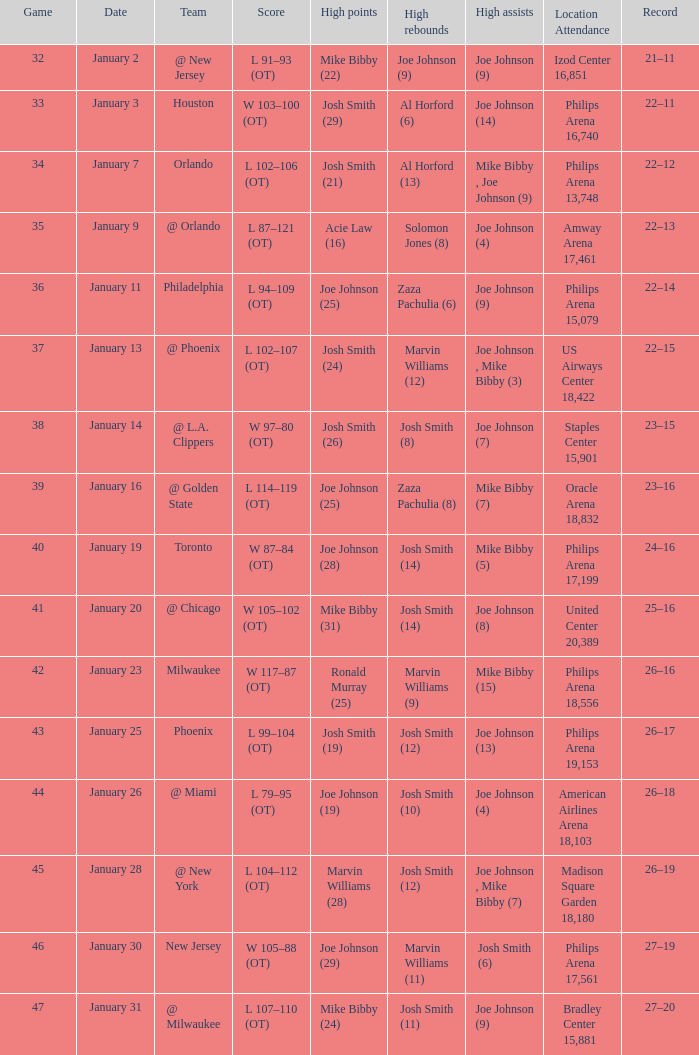Which date was game 35 on? January 9. Give me the full table as a dictionary. {'header': ['Game', 'Date', 'Team', 'Score', 'High points', 'High rebounds', 'High assists', 'Location Attendance', 'Record'], 'rows': [['32', 'January 2', '@ New Jersey', 'L 91–93 (OT)', 'Mike Bibby (22)', 'Joe Johnson (9)', 'Joe Johnson (9)', 'Izod Center 16,851', '21–11'], ['33', 'January 3', 'Houston', 'W 103–100 (OT)', 'Josh Smith (29)', 'Al Horford (6)', 'Joe Johnson (14)', 'Philips Arena 16,740', '22–11'], ['34', 'January 7', 'Orlando', 'L 102–106 (OT)', 'Josh Smith (21)', 'Al Horford (13)', 'Mike Bibby , Joe Johnson (9)', 'Philips Arena 13,748', '22–12'], ['35', 'January 9', '@ Orlando', 'L 87–121 (OT)', 'Acie Law (16)', 'Solomon Jones (8)', 'Joe Johnson (4)', 'Amway Arena 17,461', '22–13'], ['36', 'January 11', 'Philadelphia', 'L 94–109 (OT)', 'Joe Johnson (25)', 'Zaza Pachulia (6)', 'Joe Johnson (9)', 'Philips Arena 15,079', '22–14'], ['37', 'January 13', '@ Phoenix', 'L 102–107 (OT)', 'Josh Smith (24)', 'Marvin Williams (12)', 'Joe Johnson , Mike Bibby (3)', 'US Airways Center 18,422', '22–15'], ['38', 'January 14', '@ L.A. Clippers', 'W 97–80 (OT)', 'Josh Smith (26)', 'Josh Smith (8)', 'Joe Johnson (7)', 'Staples Center 15,901', '23–15'], ['39', 'January 16', '@ Golden State', 'L 114–119 (OT)', 'Joe Johnson (25)', 'Zaza Pachulia (8)', 'Mike Bibby (7)', 'Oracle Arena 18,832', '23–16'], ['40', 'January 19', 'Toronto', 'W 87–84 (OT)', 'Joe Johnson (28)', 'Josh Smith (14)', 'Mike Bibby (5)', 'Philips Arena 17,199', '24–16'], ['41', 'January 20', '@ Chicago', 'W 105–102 (OT)', 'Mike Bibby (31)', 'Josh Smith (14)', 'Joe Johnson (8)', 'United Center 20,389', '25–16'], ['42', 'January 23', 'Milwaukee', 'W 117–87 (OT)', 'Ronald Murray (25)', 'Marvin Williams (9)', 'Mike Bibby (15)', 'Philips Arena 18,556', '26–16'], ['43', 'January 25', 'Phoenix', 'L 99–104 (OT)', 'Josh Smith (19)', 'Josh Smith (12)', 'Joe Johnson (13)', 'Philips Arena 19,153', '26–17'], ['44', 'January 26', '@ Miami', 'L 79–95 (OT)', 'Joe Johnson (19)', 'Josh Smith (10)', 'Joe Johnson (4)', 'American Airlines Arena 18,103', '26–18'], ['45', 'January 28', '@ New York', 'L 104–112 (OT)', 'Marvin Williams (28)', 'Josh Smith (12)', 'Joe Johnson , Mike Bibby (7)', 'Madison Square Garden 18,180', '26–19'], ['46', 'January 30', 'New Jersey', 'W 105–88 (OT)', 'Joe Johnson (29)', 'Marvin Williams (11)', 'Josh Smith (6)', 'Philips Arena 17,561', '27–19'], ['47', 'January 31', '@ Milwaukee', 'L 107–110 (OT)', 'Mike Bibby (24)', 'Josh Smith (11)', 'Joe Johnson (9)', 'Bradley Center 15,881', '27–20']]} 